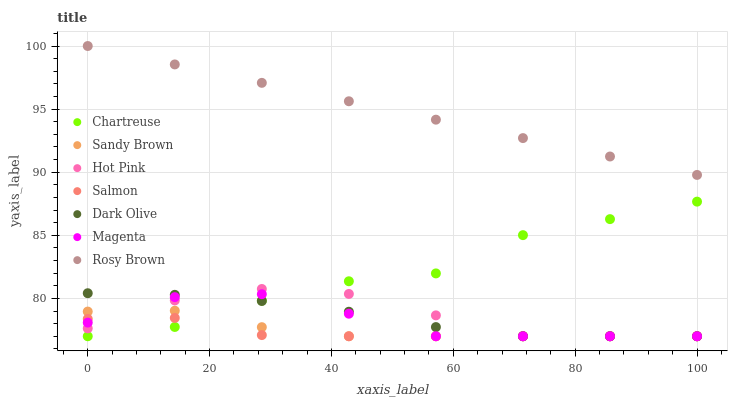Does Salmon have the minimum area under the curve?
Answer yes or no. Yes. Does Rosy Brown have the maximum area under the curve?
Answer yes or no. Yes. Does Dark Olive have the minimum area under the curve?
Answer yes or no. No. Does Dark Olive have the maximum area under the curve?
Answer yes or no. No. Is Rosy Brown the smoothest?
Answer yes or no. Yes. Is Chartreuse the roughest?
Answer yes or no. Yes. Is Dark Olive the smoothest?
Answer yes or no. No. Is Dark Olive the roughest?
Answer yes or no. No. Does Hot Pink have the lowest value?
Answer yes or no. Yes. Does Rosy Brown have the lowest value?
Answer yes or no. No. Does Rosy Brown have the highest value?
Answer yes or no. Yes. Does Dark Olive have the highest value?
Answer yes or no. No. Is Dark Olive less than Rosy Brown?
Answer yes or no. Yes. Is Rosy Brown greater than Magenta?
Answer yes or no. Yes. Does Chartreuse intersect Dark Olive?
Answer yes or no. Yes. Is Chartreuse less than Dark Olive?
Answer yes or no. No. Is Chartreuse greater than Dark Olive?
Answer yes or no. No. Does Dark Olive intersect Rosy Brown?
Answer yes or no. No. 